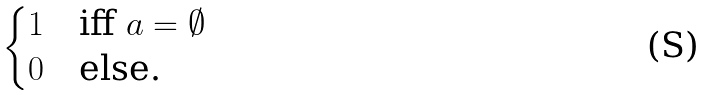Convert formula to latex. <formula><loc_0><loc_0><loc_500><loc_500>\begin{cases} 1 & \text {iff } a = \emptyset \\ 0 & \text {else.} \end{cases}</formula> 